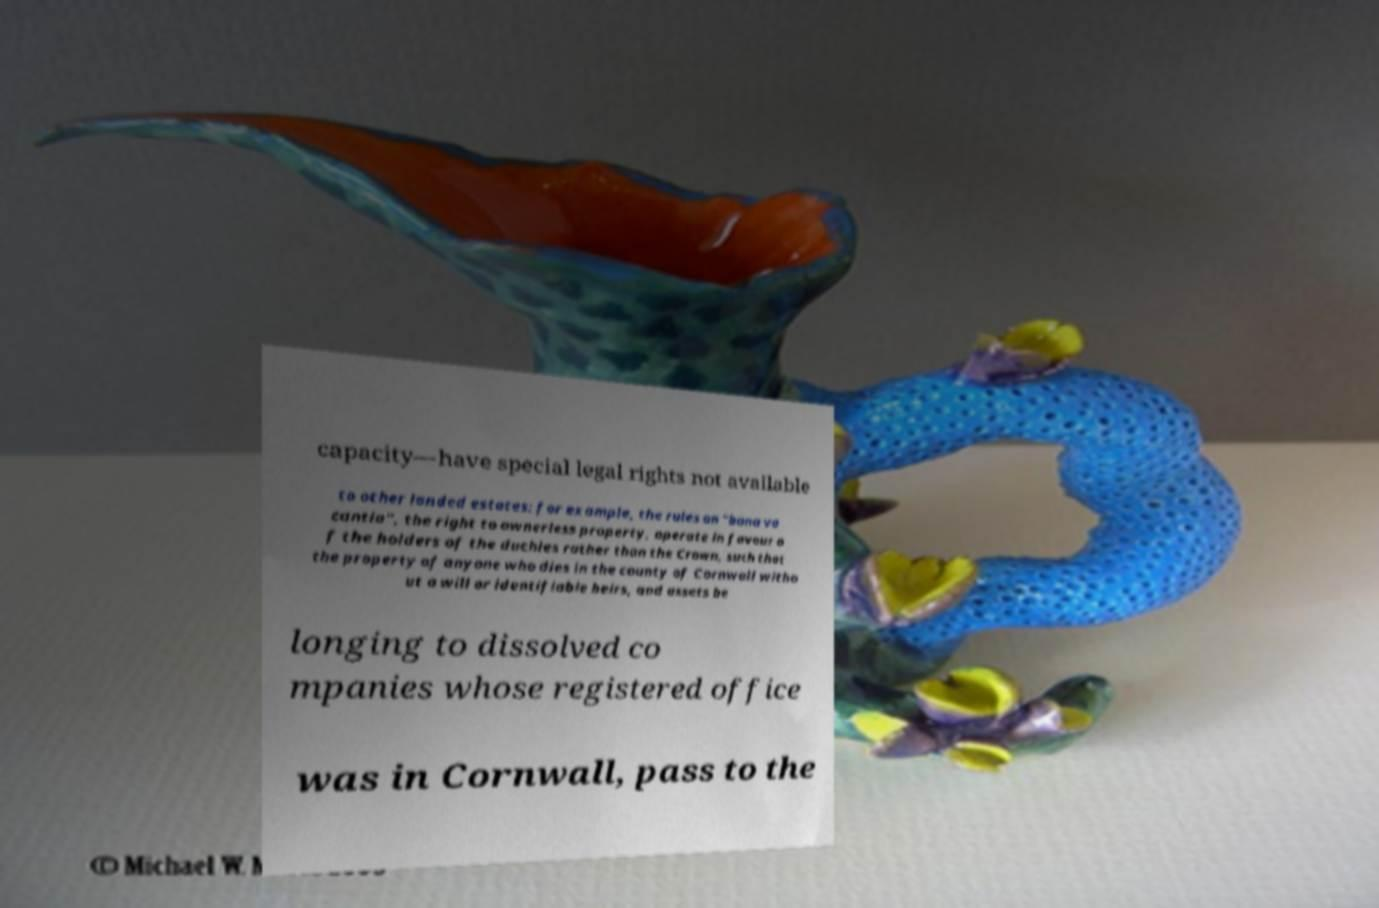Please read and relay the text visible in this image. What does it say? capacity—have special legal rights not available to other landed estates: for example, the rules on "bona va cantia", the right to ownerless property, operate in favour o f the holders of the duchies rather than the Crown, such that the property of anyone who dies in the county of Cornwall witho ut a will or identifiable heirs, and assets be longing to dissolved co mpanies whose registered office was in Cornwall, pass to the 